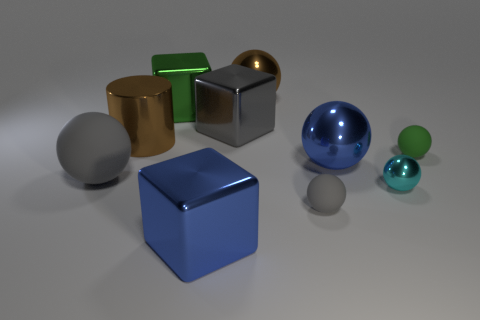Subtract all gray balls. How many were subtracted if there are1gray balls left? 1 Subtract all small green matte spheres. How many spheres are left? 5 Subtract all brown balls. How many balls are left? 5 Subtract all cyan spheres. Subtract all yellow cylinders. How many spheres are left? 5 Subtract all balls. How many objects are left? 4 Subtract 0 brown blocks. How many objects are left? 10 Subtract all large blue metal things. Subtract all gray metallic blocks. How many objects are left? 7 Add 2 large green metallic things. How many large green metallic things are left? 3 Add 5 big gray cubes. How many big gray cubes exist? 6 